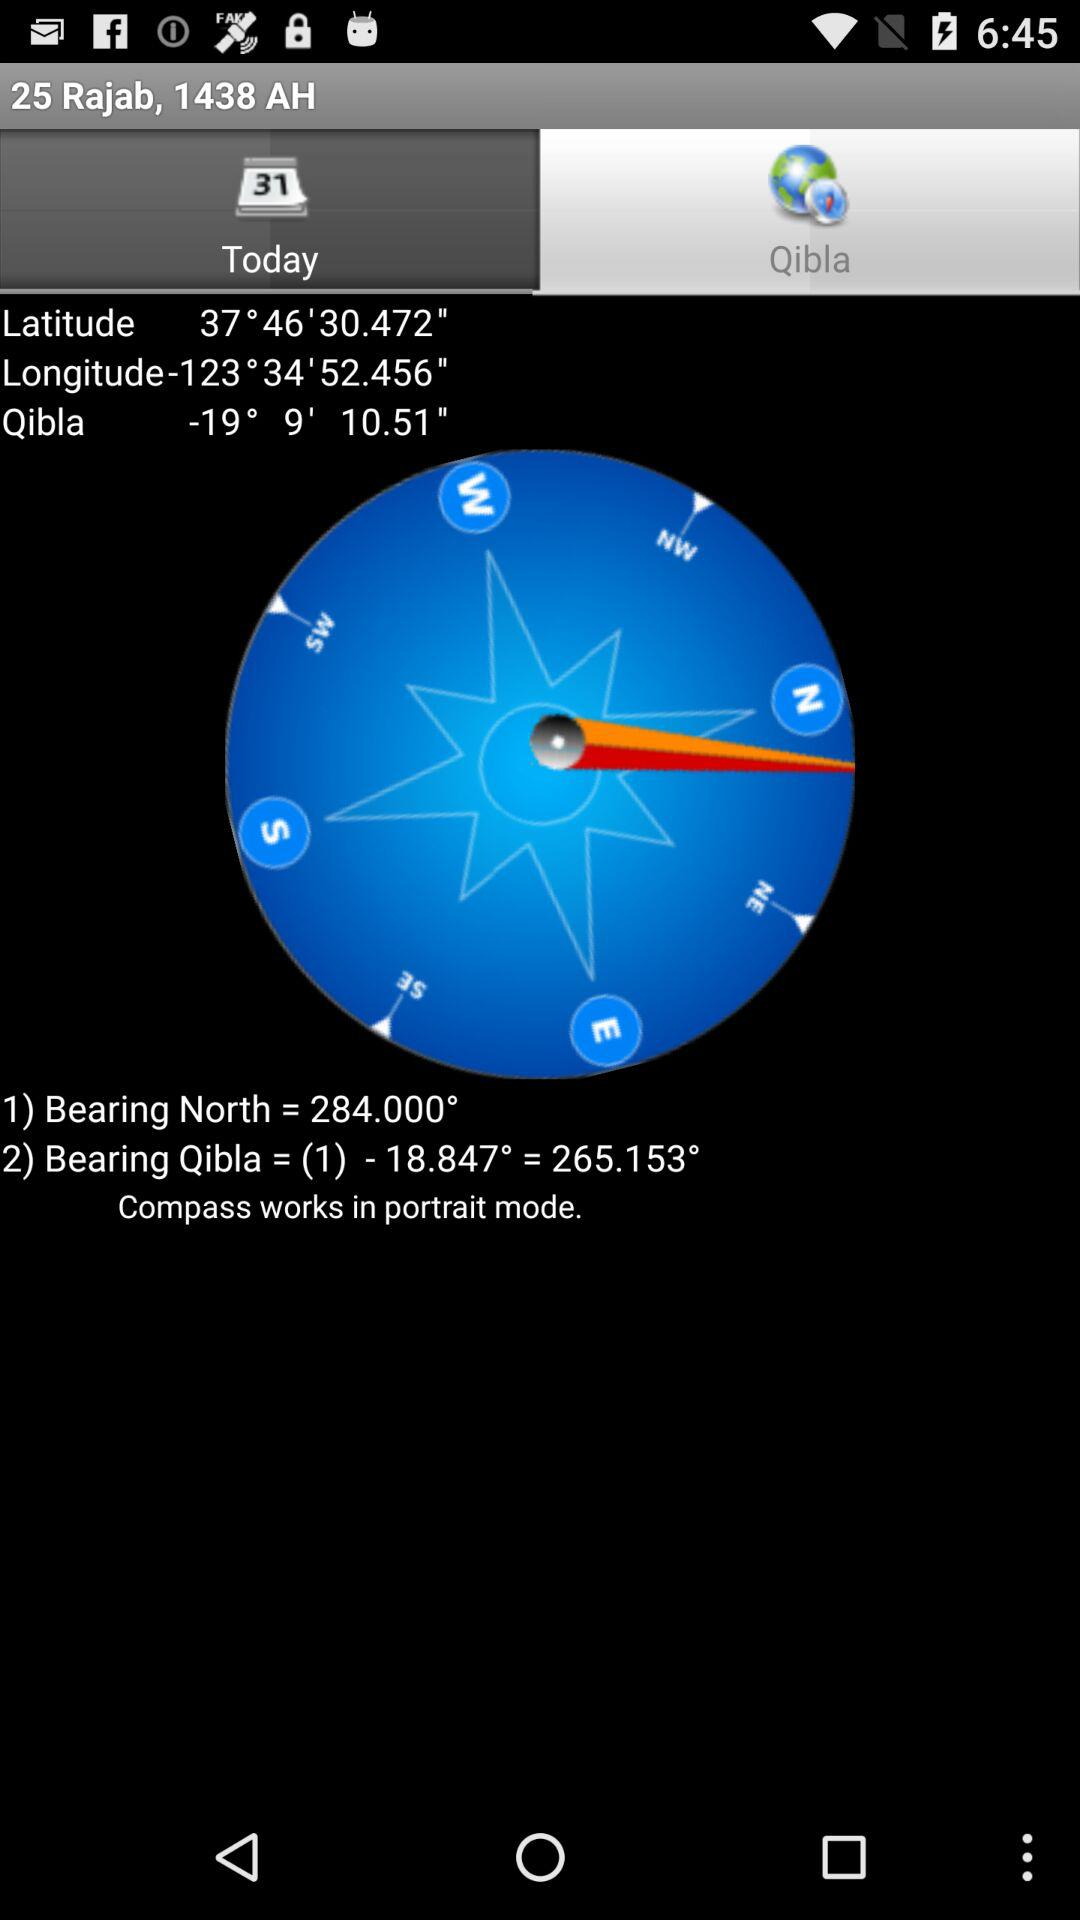What is the difference in degrees between the bearing of the north and the bearing of the qibla?
Answer the question using a single word or phrase. 18.847 